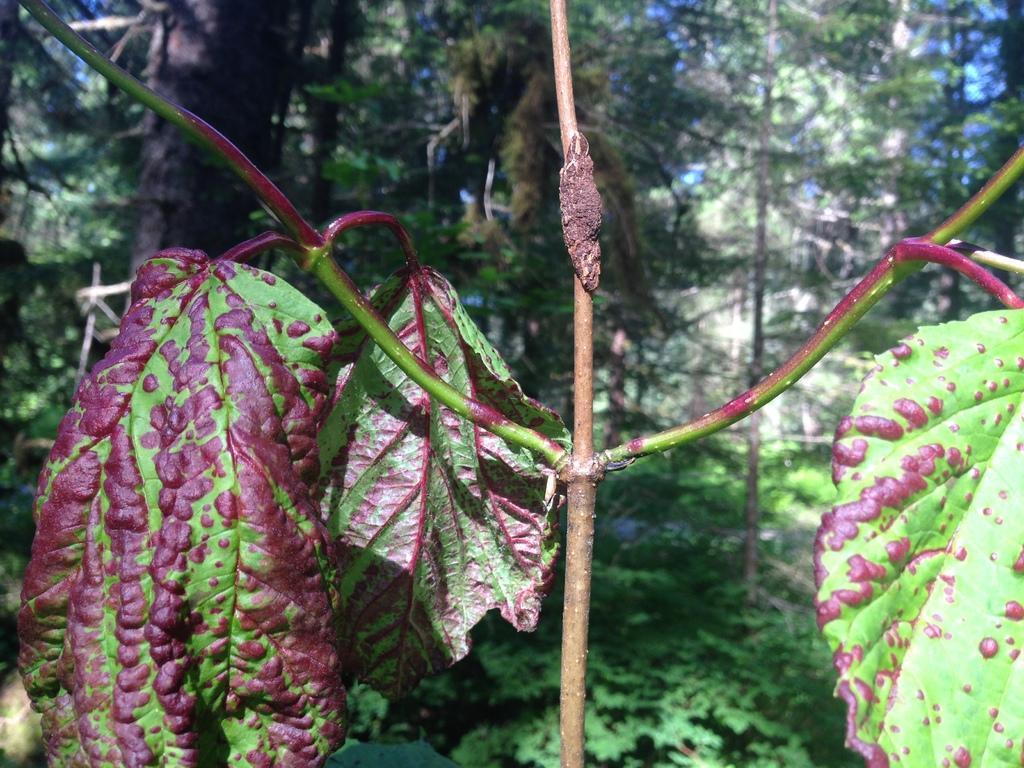How would you summarize this image in a sentence or two? In the center of the image we can see a plant with branches and leaves. In the background, we can see trees. 